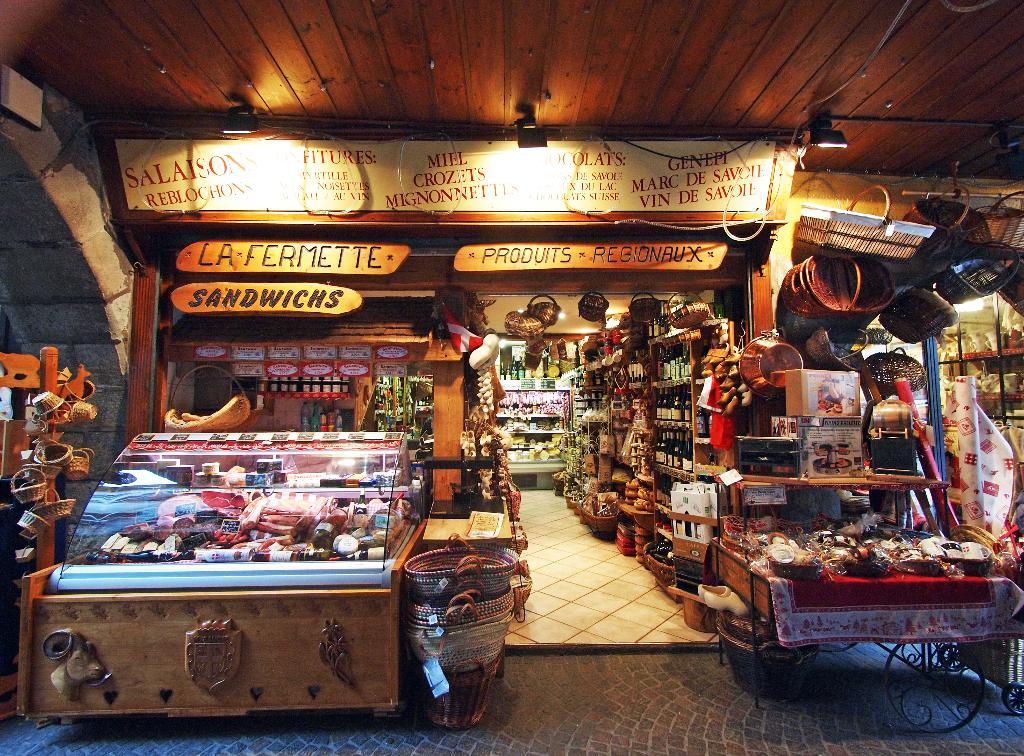What is on the sign above sandiwches?
Your answer should be compact. La fermette. What easy to eat food does this shop sell?
Your response must be concise. Sandwiches. 